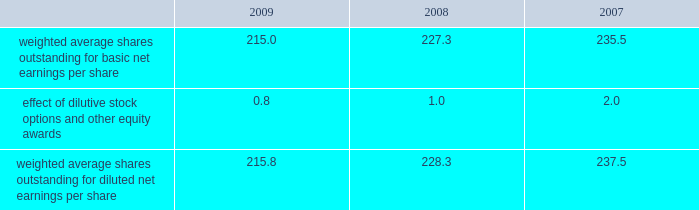14 .
Capital stock and earnings per share we are authorized to issue 250 million shares of preferred stock , none of which were issued or outstanding as of december 31 , 2009 .
The numerator for both basic and diluted earnings per share is net earnings available to common stockholders .
The denominator for basic earnings per share is the weighted average number of common shares outstanding during the period .
The denominator for diluted earnings per share is weighted average shares outstanding adjusted for the effect of dilutive stock options and other equity awards .
The following is a reconciliation of weighted average shares for the basic and diluted share computations for the years ending december 31 ( in millions ) : .
Weighted average shares outstanding for basic net earnings per share 215.0 227.3 235.5 effect of dilutive stock options and other equity awards 0.8 1.0 2.0 weighted average shares outstanding for diluted net earnings per share 215.8 228.3 237.5 for the year ended december 31 , 2009 , an average of 14.3 million options to purchase shares of common stock were not included in the computation of diluted earnings per share as the exercise prices of these options were greater than the average market price of the common stock .
For the years ended december 31 , 2008 and 2007 , an average of 11.2 million and 3.1 million options , respectively , were not included .
During 2009 , we repurchased approximately 19.8 million shares of our common stock at an average price of $ 46.56 per share for a total cash outlay of $ 923.7 million , including commissions .
In april 2008 , we announced that our board of directors authorized a $ 1.25 billion share repurchase program which was originally set to expire on december 31 , 2009 .
In september 2009 , the board of directors extended this program to december 31 , 2010 .
Approximately $ 211.1 million remains authorized for future repurchases under this plan .
15 .
Segment data we design , develop , manufacture and market orthopaedic reconstructive implants , dental implants , spinal implants , trauma products and related surgical products which include surgical supplies and instruments designed to aid in surgical procedures and post-operation rehabilitation .
We also provide other healthcare-related services .
Revenue related to these services currently represents less than 1 percent of our total net sales .
We manage operations through three major geographic segments 2013 the americas , which is comprised principally of the united states and includes other north , central and south american markets ; europe , which is comprised principally of europe and includes the middle east and africa ; and asia pacific , which is comprised primarily of japan and includes other asian and pacific markets .
This structure is the basis for our reportable segment information discussed below .
Management evaluates reportable segment performance based upon segment operating profit exclusive of operating expenses pertaining to global operations and corporate expenses , share-based compensation expense , settlement , certain claims , acquisition , integration , realignment and other expenses , net curtailment and settlement , inventory step-up , in-process research and development write-offs and intangible asset amortization expense .
Global operations include research , development engineering , medical education , brand management , corporate legal , finance , and human resource functions and u.s .
And puerto rico-based manufacturing operations and logistics .
Intercompany transactions have been eliminated from segment operating profit .
Management reviews accounts receivable , inventory , property , plant and equipment , goodwill and intangible assets by reportable segment exclusive of u.s .
And puerto rico-based manufacturing operations and logistics and corporate assets .
Z i m m e r h o l d i n g s , i n c .
2 0 0 9 f o r m 1 0 - k a n n u a l r e p o r t notes to consolidated financial statements ( continued ) %%transmsg*** transmitting job : c55340 pcn : 060000000 ***%%pcmsg|60 |00007|yes|no|02/24/2010 01:32|0|0|page is valid , no graphics -- color : d| .
What is the percent change in weighted average shares outstanding for basic net earnings per share between 2007 and 2009? 
Computations: ((215.0 - 235.5) / 235.5)
Answer: -0.08705. 